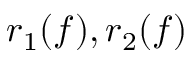<formula> <loc_0><loc_0><loc_500><loc_500>r _ { 1 } ( f ) , r _ { 2 } ( f )</formula> 